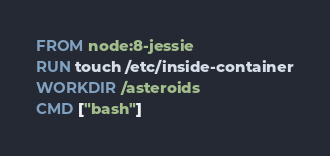Convert code to text. <code><loc_0><loc_0><loc_500><loc_500><_Dockerfile_>FROM node:8-jessie
RUN touch /etc/inside-container
WORKDIR /asteroids
CMD ["bash"]
</code> 